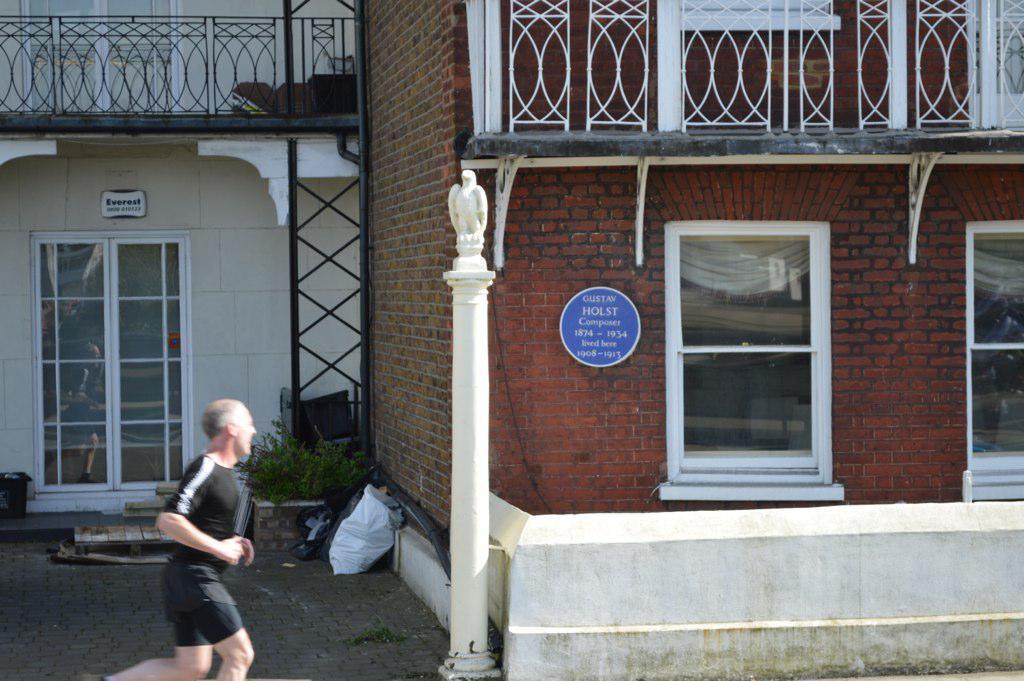How would you summarize this image in a sentence or two? In the bottom left corner we can see a man is running. In the background of the image we can see the buildings, railing, door, windows, boards, rods, pole, planter, bags and container. At the bottom of the image we can see the pavement. 